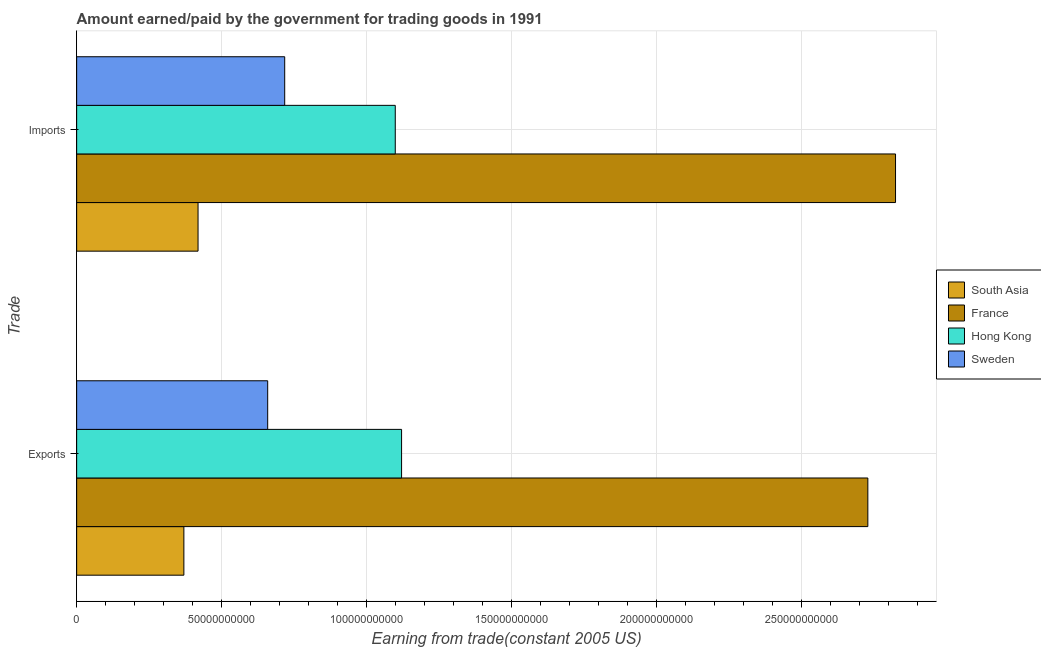How many different coloured bars are there?
Give a very brief answer. 4. How many groups of bars are there?
Make the answer very short. 2. How many bars are there on the 1st tick from the top?
Make the answer very short. 4. How many bars are there on the 1st tick from the bottom?
Ensure brevity in your answer.  4. What is the label of the 1st group of bars from the top?
Ensure brevity in your answer.  Imports. What is the amount earned from exports in France?
Your answer should be very brief. 2.73e+11. Across all countries, what is the maximum amount paid for imports?
Your answer should be very brief. 2.82e+11. Across all countries, what is the minimum amount earned from exports?
Offer a very short reply. 3.70e+1. In which country was the amount paid for imports minimum?
Offer a very short reply. South Asia. What is the total amount earned from exports in the graph?
Give a very brief answer. 4.88e+11. What is the difference between the amount paid for imports in Hong Kong and that in France?
Keep it short and to the point. -1.73e+11. What is the difference between the amount earned from exports in France and the amount paid for imports in Hong Kong?
Give a very brief answer. 1.63e+11. What is the average amount earned from exports per country?
Give a very brief answer. 1.22e+11. What is the difference between the amount earned from exports and amount paid for imports in Hong Kong?
Your answer should be compact. 2.17e+09. In how many countries, is the amount paid for imports greater than 200000000000 US$?
Your response must be concise. 1. What is the ratio of the amount earned from exports in Hong Kong to that in South Asia?
Offer a terse response. 3.03. Is the amount earned from exports in Hong Kong less than that in South Asia?
Make the answer very short. No. What does the 3rd bar from the bottom in Imports represents?
Offer a terse response. Hong Kong. How many countries are there in the graph?
Provide a short and direct response. 4. How many legend labels are there?
Offer a very short reply. 4. How are the legend labels stacked?
Your answer should be compact. Vertical. What is the title of the graph?
Your answer should be compact. Amount earned/paid by the government for trading goods in 1991. What is the label or title of the X-axis?
Make the answer very short. Earning from trade(constant 2005 US). What is the label or title of the Y-axis?
Your response must be concise. Trade. What is the Earning from trade(constant 2005 US) in South Asia in Exports?
Provide a succinct answer. 3.70e+1. What is the Earning from trade(constant 2005 US) of France in Exports?
Provide a succinct answer. 2.73e+11. What is the Earning from trade(constant 2005 US) of Hong Kong in Exports?
Offer a very short reply. 1.12e+11. What is the Earning from trade(constant 2005 US) of Sweden in Exports?
Offer a terse response. 6.59e+1. What is the Earning from trade(constant 2005 US) in South Asia in Imports?
Provide a succinct answer. 4.19e+1. What is the Earning from trade(constant 2005 US) of France in Imports?
Provide a short and direct response. 2.82e+11. What is the Earning from trade(constant 2005 US) of Hong Kong in Imports?
Make the answer very short. 1.10e+11. What is the Earning from trade(constant 2005 US) in Sweden in Imports?
Make the answer very short. 7.18e+1. Across all Trade, what is the maximum Earning from trade(constant 2005 US) in South Asia?
Your answer should be very brief. 4.19e+1. Across all Trade, what is the maximum Earning from trade(constant 2005 US) of France?
Make the answer very short. 2.82e+11. Across all Trade, what is the maximum Earning from trade(constant 2005 US) in Hong Kong?
Offer a terse response. 1.12e+11. Across all Trade, what is the maximum Earning from trade(constant 2005 US) in Sweden?
Your answer should be compact. 7.18e+1. Across all Trade, what is the minimum Earning from trade(constant 2005 US) of South Asia?
Offer a very short reply. 3.70e+1. Across all Trade, what is the minimum Earning from trade(constant 2005 US) of France?
Provide a short and direct response. 2.73e+11. Across all Trade, what is the minimum Earning from trade(constant 2005 US) of Hong Kong?
Give a very brief answer. 1.10e+11. Across all Trade, what is the minimum Earning from trade(constant 2005 US) of Sweden?
Your answer should be compact. 6.59e+1. What is the total Earning from trade(constant 2005 US) in South Asia in the graph?
Keep it short and to the point. 7.89e+1. What is the total Earning from trade(constant 2005 US) of France in the graph?
Your answer should be very brief. 5.55e+11. What is the total Earning from trade(constant 2005 US) of Hong Kong in the graph?
Your answer should be compact. 2.22e+11. What is the total Earning from trade(constant 2005 US) of Sweden in the graph?
Offer a terse response. 1.38e+11. What is the difference between the Earning from trade(constant 2005 US) of South Asia in Exports and that in Imports?
Your answer should be very brief. -4.89e+09. What is the difference between the Earning from trade(constant 2005 US) in France in Exports and that in Imports?
Offer a terse response. -9.55e+09. What is the difference between the Earning from trade(constant 2005 US) of Hong Kong in Exports and that in Imports?
Offer a terse response. 2.17e+09. What is the difference between the Earning from trade(constant 2005 US) in Sweden in Exports and that in Imports?
Give a very brief answer. -5.87e+09. What is the difference between the Earning from trade(constant 2005 US) of South Asia in Exports and the Earning from trade(constant 2005 US) of France in Imports?
Offer a terse response. -2.45e+11. What is the difference between the Earning from trade(constant 2005 US) in South Asia in Exports and the Earning from trade(constant 2005 US) in Hong Kong in Imports?
Your answer should be very brief. -7.29e+1. What is the difference between the Earning from trade(constant 2005 US) of South Asia in Exports and the Earning from trade(constant 2005 US) of Sweden in Imports?
Make the answer very short. -3.48e+1. What is the difference between the Earning from trade(constant 2005 US) in France in Exports and the Earning from trade(constant 2005 US) in Hong Kong in Imports?
Provide a short and direct response. 1.63e+11. What is the difference between the Earning from trade(constant 2005 US) in France in Exports and the Earning from trade(constant 2005 US) in Sweden in Imports?
Offer a very short reply. 2.01e+11. What is the difference between the Earning from trade(constant 2005 US) of Hong Kong in Exports and the Earning from trade(constant 2005 US) of Sweden in Imports?
Your answer should be very brief. 4.03e+1. What is the average Earning from trade(constant 2005 US) of South Asia per Trade?
Give a very brief answer. 3.94e+1. What is the average Earning from trade(constant 2005 US) in France per Trade?
Your answer should be very brief. 2.78e+11. What is the average Earning from trade(constant 2005 US) of Hong Kong per Trade?
Offer a terse response. 1.11e+11. What is the average Earning from trade(constant 2005 US) of Sweden per Trade?
Provide a succinct answer. 6.88e+1. What is the difference between the Earning from trade(constant 2005 US) of South Asia and Earning from trade(constant 2005 US) of France in Exports?
Offer a terse response. -2.36e+11. What is the difference between the Earning from trade(constant 2005 US) in South Asia and Earning from trade(constant 2005 US) in Hong Kong in Exports?
Your answer should be compact. -7.51e+1. What is the difference between the Earning from trade(constant 2005 US) of South Asia and Earning from trade(constant 2005 US) of Sweden in Exports?
Your response must be concise. -2.89e+1. What is the difference between the Earning from trade(constant 2005 US) of France and Earning from trade(constant 2005 US) of Hong Kong in Exports?
Offer a terse response. 1.61e+11. What is the difference between the Earning from trade(constant 2005 US) of France and Earning from trade(constant 2005 US) of Sweden in Exports?
Your answer should be compact. 2.07e+11. What is the difference between the Earning from trade(constant 2005 US) of Hong Kong and Earning from trade(constant 2005 US) of Sweden in Exports?
Ensure brevity in your answer.  4.62e+1. What is the difference between the Earning from trade(constant 2005 US) in South Asia and Earning from trade(constant 2005 US) in France in Imports?
Provide a succinct answer. -2.41e+11. What is the difference between the Earning from trade(constant 2005 US) in South Asia and Earning from trade(constant 2005 US) in Hong Kong in Imports?
Your response must be concise. -6.80e+1. What is the difference between the Earning from trade(constant 2005 US) in South Asia and Earning from trade(constant 2005 US) in Sweden in Imports?
Your answer should be compact. -2.99e+1. What is the difference between the Earning from trade(constant 2005 US) in France and Earning from trade(constant 2005 US) in Hong Kong in Imports?
Keep it short and to the point. 1.73e+11. What is the difference between the Earning from trade(constant 2005 US) of France and Earning from trade(constant 2005 US) of Sweden in Imports?
Provide a short and direct response. 2.11e+11. What is the difference between the Earning from trade(constant 2005 US) of Hong Kong and Earning from trade(constant 2005 US) of Sweden in Imports?
Provide a succinct answer. 3.81e+1. What is the ratio of the Earning from trade(constant 2005 US) of South Asia in Exports to that in Imports?
Make the answer very short. 0.88. What is the ratio of the Earning from trade(constant 2005 US) in France in Exports to that in Imports?
Provide a succinct answer. 0.97. What is the ratio of the Earning from trade(constant 2005 US) in Hong Kong in Exports to that in Imports?
Ensure brevity in your answer.  1.02. What is the ratio of the Earning from trade(constant 2005 US) in Sweden in Exports to that in Imports?
Offer a terse response. 0.92. What is the difference between the highest and the second highest Earning from trade(constant 2005 US) in South Asia?
Provide a succinct answer. 4.89e+09. What is the difference between the highest and the second highest Earning from trade(constant 2005 US) of France?
Keep it short and to the point. 9.55e+09. What is the difference between the highest and the second highest Earning from trade(constant 2005 US) of Hong Kong?
Give a very brief answer. 2.17e+09. What is the difference between the highest and the second highest Earning from trade(constant 2005 US) in Sweden?
Your response must be concise. 5.87e+09. What is the difference between the highest and the lowest Earning from trade(constant 2005 US) of South Asia?
Keep it short and to the point. 4.89e+09. What is the difference between the highest and the lowest Earning from trade(constant 2005 US) of France?
Provide a short and direct response. 9.55e+09. What is the difference between the highest and the lowest Earning from trade(constant 2005 US) of Hong Kong?
Offer a very short reply. 2.17e+09. What is the difference between the highest and the lowest Earning from trade(constant 2005 US) of Sweden?
Make the answer very short. 5.87e+09. 